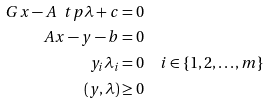<formula> <loc_0><loc_0><loc_500><loc_500>G x - A ^ { \ } t p \lambda + c = 0 & \\ A x - y - b = 0 & \\ y _ { i } \lambda _ { i } = 0 & \quad i \in \{ 1 , 2 , \dots , m \} \\ ( y , \lambda ) \geq 0 &</formula> 